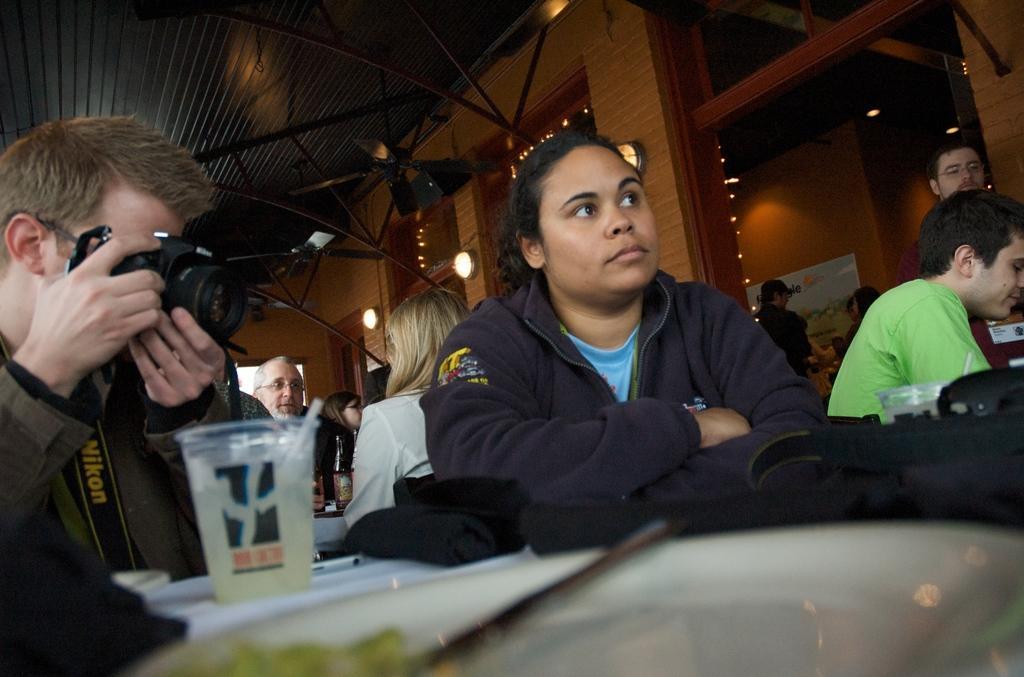Can you describe this image briefly? In the picture we can see some people are sitting on the chairs near the table, one man is holding a camera and capturing something and beside him we can see a woman sitting with a black color hoodie and behind them also we can see some people are sitting on the chairs near the table and on the table we can see a glass with straw and some papers on it and in the background we can see a wall with some window frames and light and to the ceiling also we can see some iron rods and lights. 